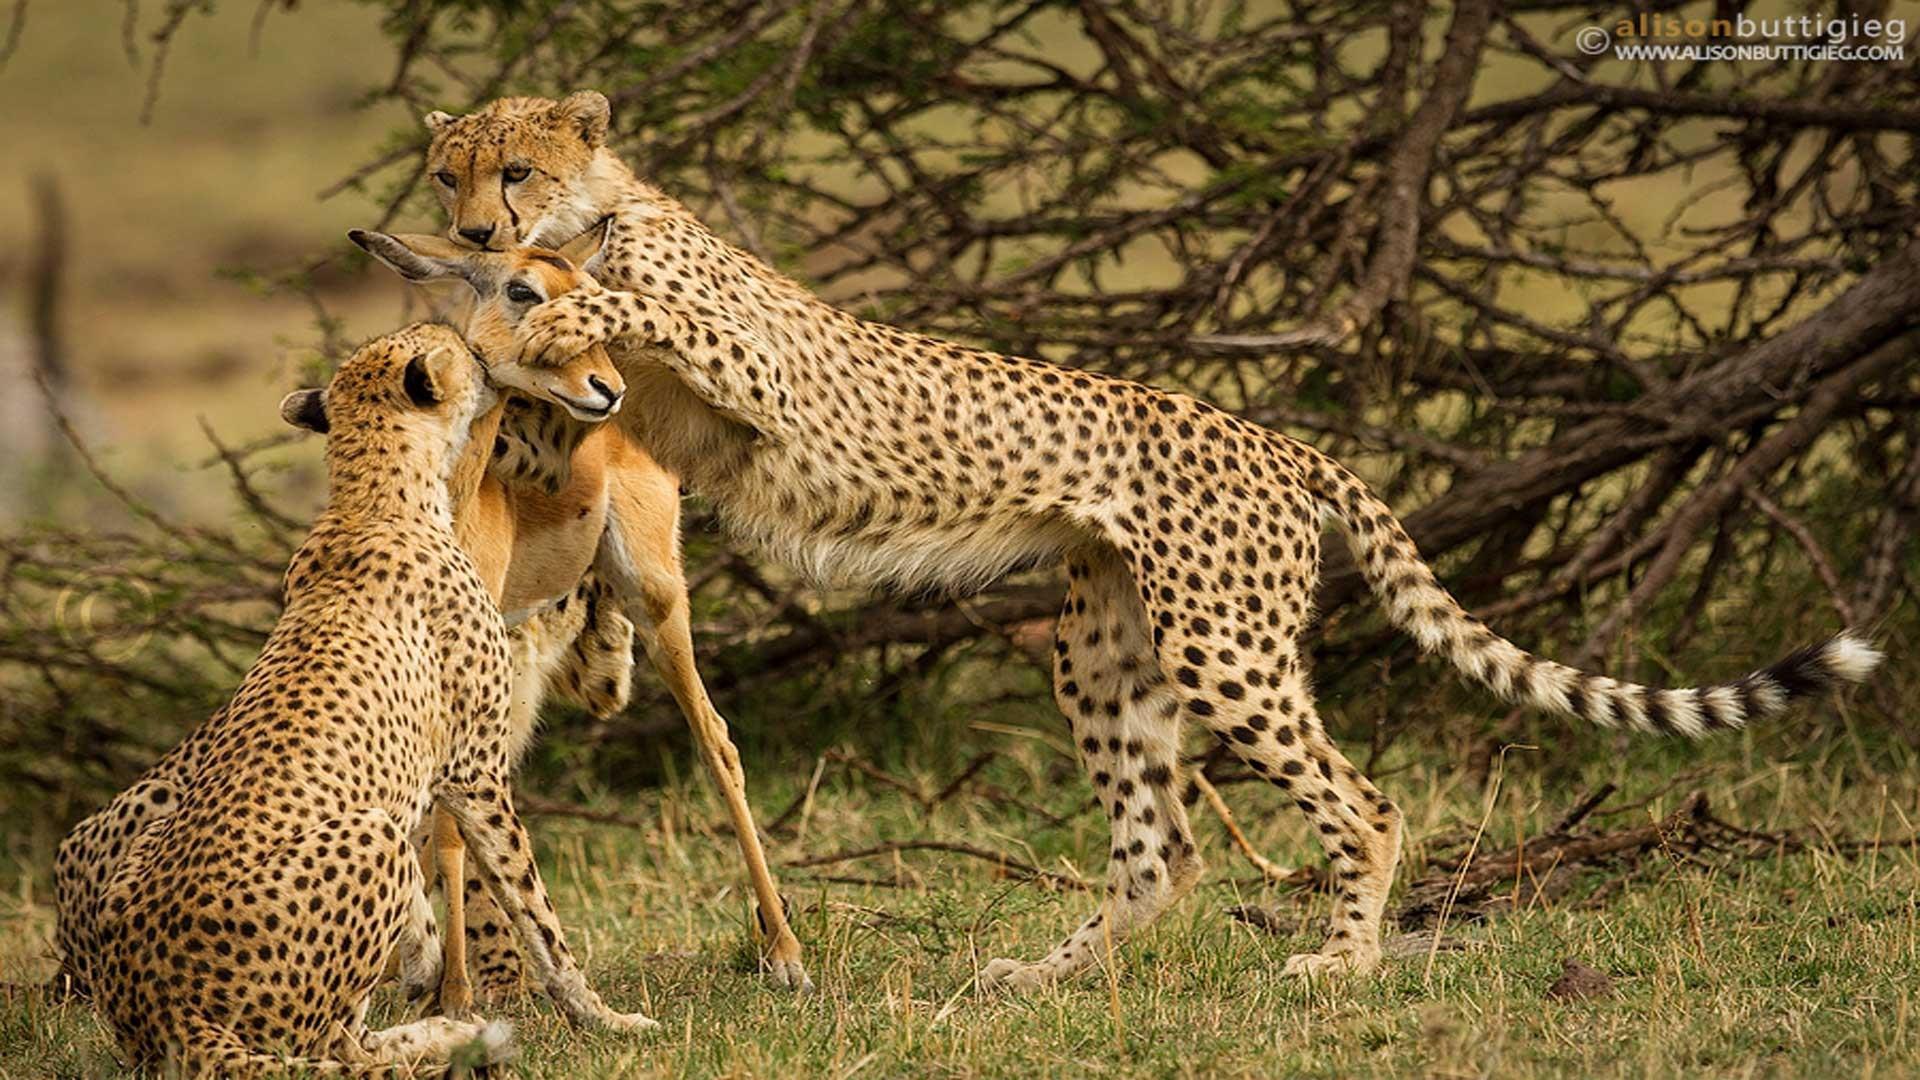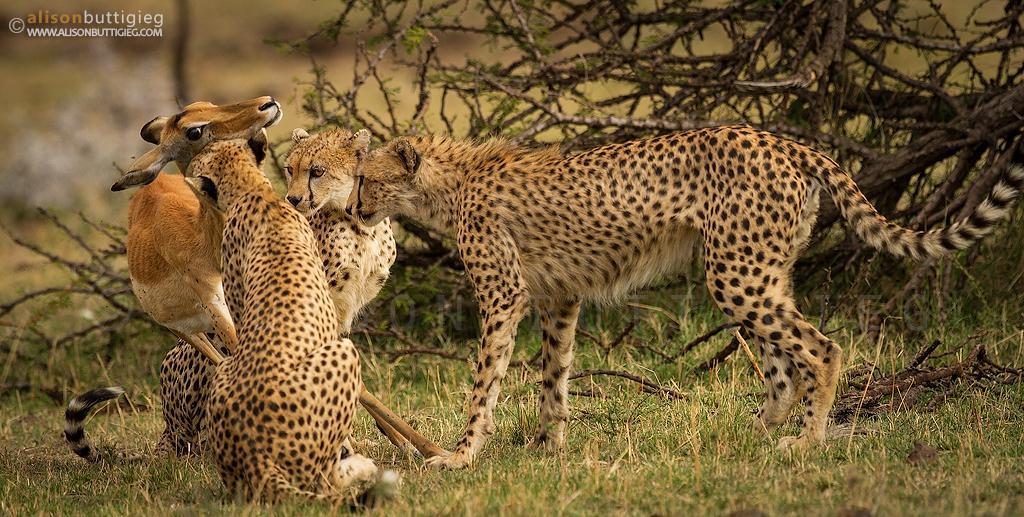The first image is the image on the left, the second image is the image on the right. Given the left and right images, does the statement "A cheetah's paw is on a deer's face in at last one of the images." hold true? Answer yes or no. Yes. 